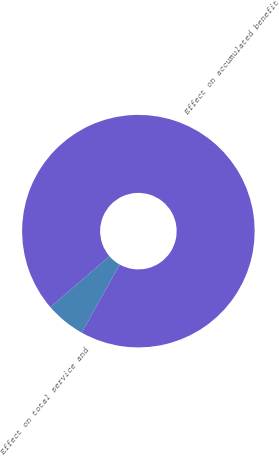Convert chart. <chart><loc_0><loc_0><loc_500><loc_500><pie_chart><fcel>Effect on total service and<fcel>Effect on accumulated benefit<nl><fcel>5.56%<fcel>94.44%<nl></chart> 